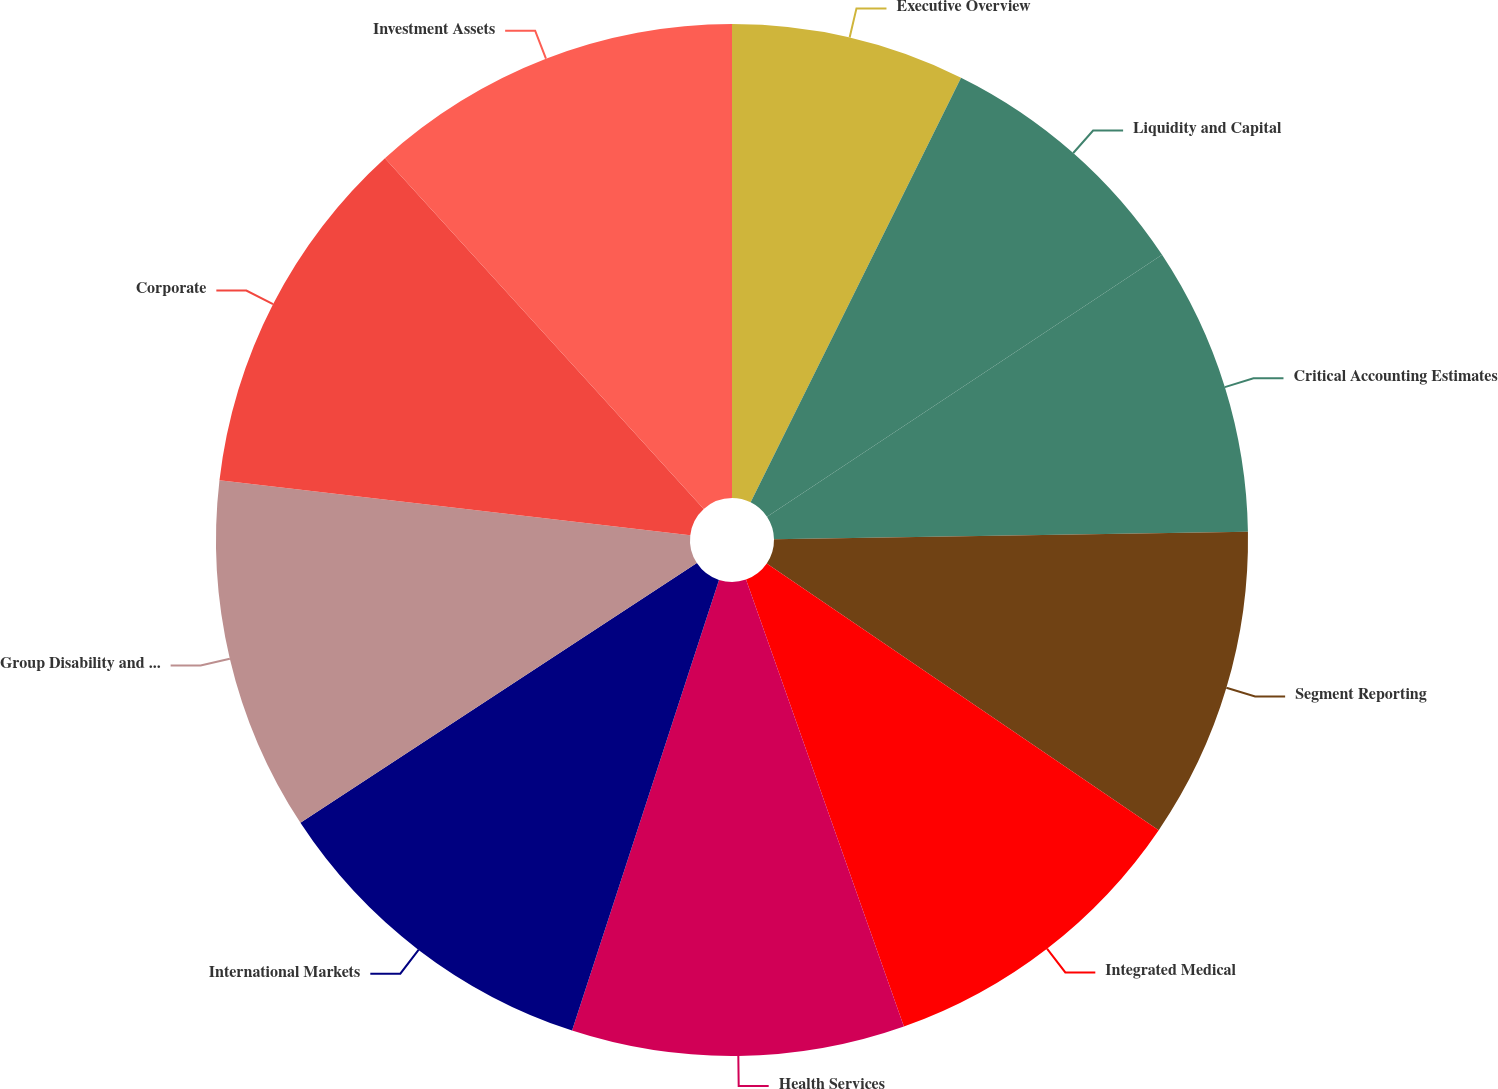Convert chart. <chart><loc_0><loc_0><loc_500><loc_500><pie_chart><fcel>Executive Overview<fcel>Liquidity and Capital<fcel>Critical Accounting Estimates<fcel>Segment Reporting<fcel>Integrated Medical<fcel>Health Services<fcel>International Markets<fcel>Group Disability and Other<fcel>Corporate<fcel>Investment Assets<nl><fcel>7.32%<fcel>8.36%<fcel>9.06%<fcel>9.76%<fcel>10.09%<fcel>10.42%<fcel>10.75%<fcel>11.08%<fcel>11.41%<fcel>11.74%<nl></chart> 